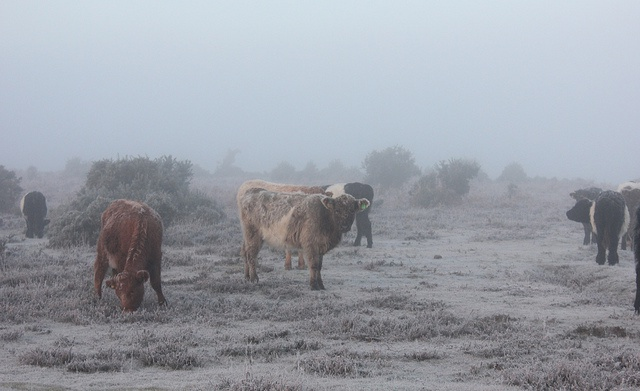Describe the objects in this image and their specific colors. I can see cow in lightgray and gray tones, cow in lightgray, gray, and black tones, cow in lightgray and gray tones, cow in lightgray, gray, and darkgray tones, and cow in lightgray, gray, darkgray, and black tones in this image. 